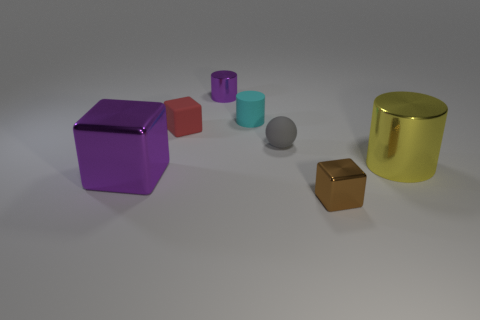Subtract 1 blocks. How many blocks are left? 2 Add 2 purple cylinders. How many objects exist? 9 Subtract all cylinders. How many objects are left? 4 Subtract all big gray things. Subtract all tiny purple metal cylinders. How many objects are left? 6 Add 3 tiny cylinders. How many tiny cylinders are left? 5 Add 1 big gray cylinders. How many big gray cylinders exist? 1 Subtract 1 gray spheres. How many objects are left? 6 